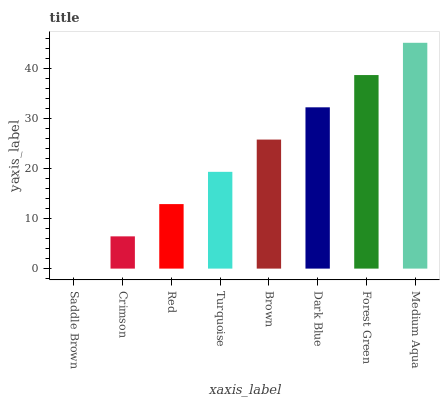Is Medium Aqua the maximum?
Answer yes or no. Yes. Is Crimson the minimum?
Answer yes or no. No. Is Crimson the maximum?
Answer yes or no. No. Is Crimson greater than Saddle Brown?
Answer yes or no. Yes. Is Saddle Brown less than Crimson?
Answer yes or no. Yes. Is Saddle Brown greater than Crimson?
Answer yes or no. No. Is Crimson less than Saddle Brown?
Answer yes or no. No. Is Brown the high median?
Answer yes or no. Yes. Is Turquoise the low median?
Answer yes or no. Yes. Is Turquoise the high median?
Answer yes or no. No. Is Crimson the low median?
Answer yes or no. No. 